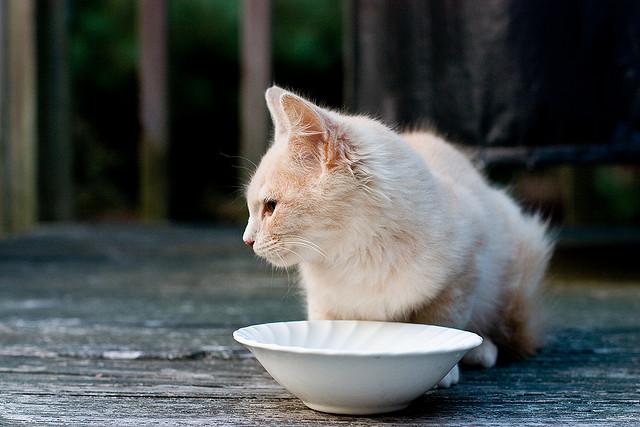What color is the cat?
Quick response, please. White. What is the cat drinking?
Answer briefly. Water. Is the bowl full?
Answer briefly. No. 